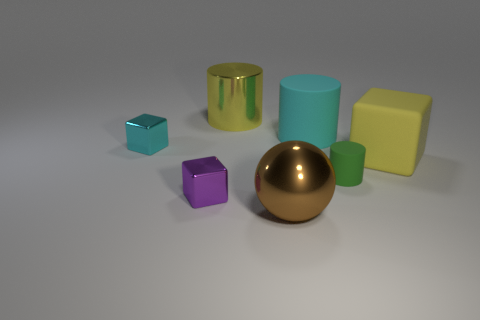Which object stands out the most and why? The golden sphere stands out prominently due to its reflective metallic finish that contrasts with the matte surfaces of the other objects. Its central placement and the way it captures the light draw the eye to it more than the other geometric shapes. 